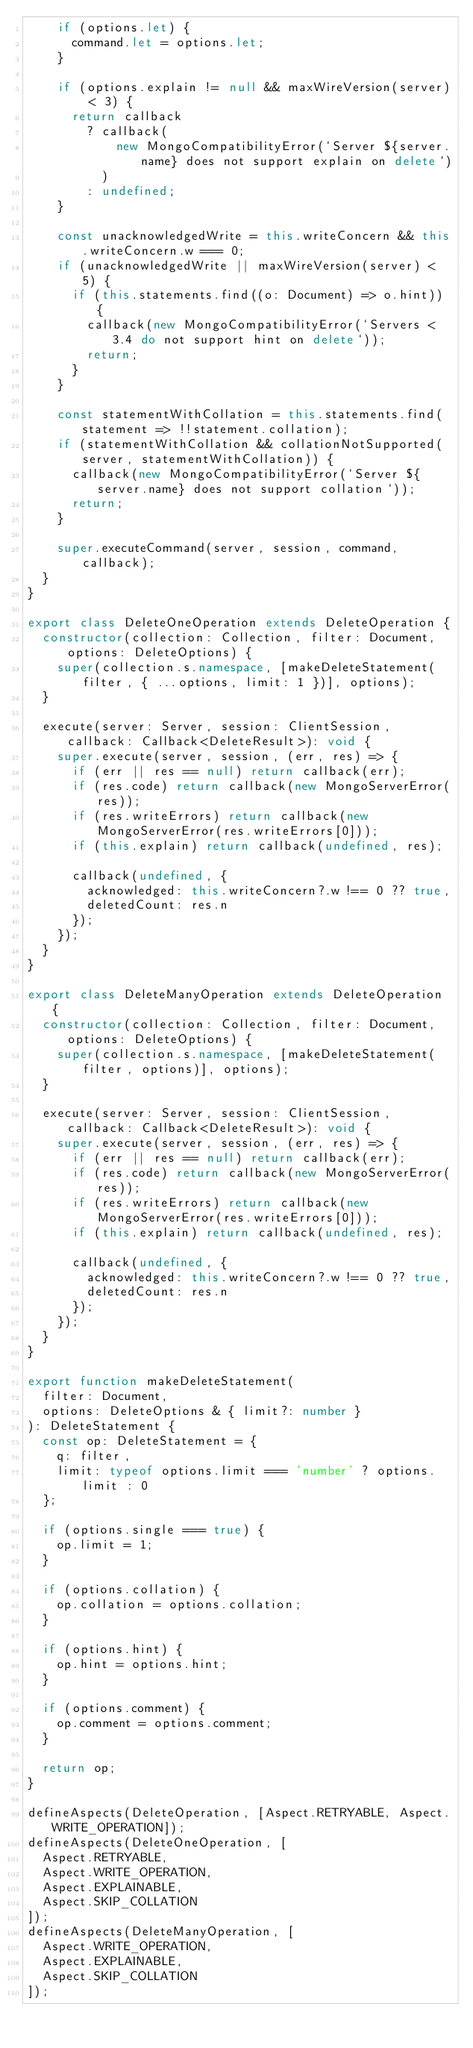Convert code to text. <code><loc_0><loc_0><loc_500><loc_500><_TypeScript_>    if (options.let) {
      command.let = options.let;
    }

    if (options.explain != null && maxWireVersion(server) < 3) {
      return callback
        ? callback(
            new MongoCompatibilityError(`Server ${server.name} does not support explain on delete`)
          )
        : undefined;
    }

    const unacknowledgedWrite = this.writeConcern && this.writeConcern.w === 0;
    if (unacknowledgedWrite || maxWireVersion(server) < 5) {
      if (this.statements.find((o: Document) => o.hint)) {
        callback(new MongoCompatibilityError(`Servers < 3.4 do not support hint on delete`));
        return;
      }
    }

    const statementWithCollation = this.statements.find(statement => !!statement.collation);
    if (statementWithCollation && collationNotSupported(server, statementWithCollation)) {
      callback(new MongoCompatibilityError(`Server ${server.name} does not support collation`));
      return;
    }

    super.executeCommand(server, session, command, callback);
  }
}

export class DeleteOneOperation extends DeleteOperation {
  constructor(collection: Collection, filter: Document, options: DeleteOptions) {
    super(collection.s.namespace, [makeDeleteStatement(filter, { ...options, limit: 1 })], options);
  }

  execute(server: Server, session: ClientSession, callback: Callback<DeleteResult>): void {
    super.execute(server, session, (err, res) => {
      if (err || res == null) return callback(err);
      if (res.code) return callback(new MongoServerError(res));
      if (res.writeErrors) return callback(new MongoServerError(res.writeErrors[0]));
      if (this.explain) return callback(undefined, res);

      callback(undefined, {
        acknowledged: this.writeConcern?.w !== 0 ?? true,
        deletedCount: res.n
      });
    });
  }
}

export class DeleteManyOperation extends DeleteOperation {
  constructor(collection: Collection, filter: Document, options: DeleteOptions) {
    super(collection.s.namespace, [makeDeleteStatement(filter, options)], options);
  }

  execute(server: Server, session: ClientSession, callback: Callback<DeleteResult>): void {
    super.execute(server, session, (err, res) => {
      if (err || res == null) return callback(err);
      if (res.code) return callback(new MongoServerError(res));
      if (res.writeErrors) return callback(new MongoServerError(res.writeErrors[0]));
      if (this.explain) return callback(undefined, res);

      callback(undefined, {
        acknowledged: this.writeConcern?.w !== 0 ?? true,
        deletedCount: res.n
      });
    });
  }
}

export function makeDeleteStatement(
  filter: Document,
  options: DeleteOptions & { limit?: number }
): DeleteStatement {
  const op: DeleteStatement = {
    q: filter,
    limit: typeof options.limit === 'number' ? options.limit : 0
  };

  if (options.single === true) {
    op.limit = 1;
  }

  if (options.collation) {
    op.collation = options.collation;
  }

  if (options.hint) {
    op.hint = options.hint;
  }

  if (options.comment) {
    op.comment = options.comment;
  }

  return op;
}

defineAspects(DeleteOperation, [Aspect.RETRYABLE, Aspect.WRITE_OPERATION]);
defineAspects(DeleteOneOperation, [
  Aspect.RETRYABLE,
  Aspect.WRITE_OPERATION,
  Aspect.EXPLAINABLE,
  Aspect.SKIP_COLLATION
]);
defineAspects(DeleteManyOperation, [
  Aspect.WRITE_OPERATION,
  Aspect.EXPLAINABLE,
  Aspect.SKIP_COLLATION
]);
</code> 